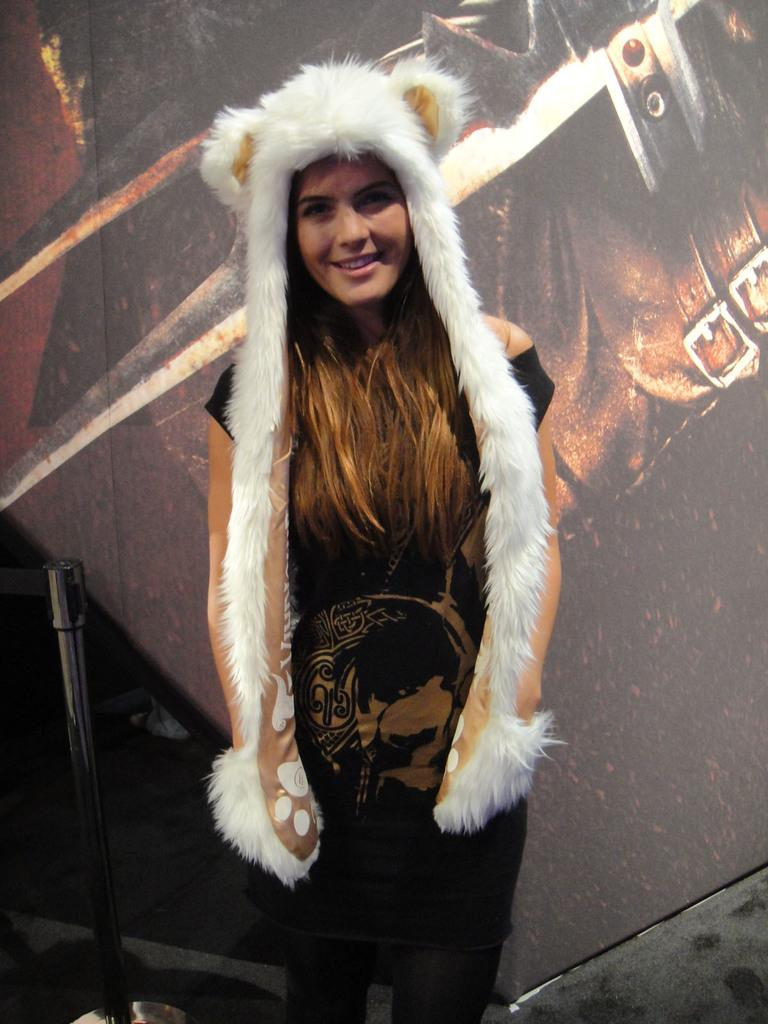What is the main subject of the image? The main subject of the image is a woman. What is the woman wearing in the image? The woman is wearing a black dress in the image. What is the woman's facial expression in the image? The woman is smiling in the image. What type of agreement is the woman signing in the image? There is no agreement or signing activity depicted in the image; the woman is simply smiling. What type of treatment is the woman receiving from the queen in the image? There is no queen or treatment activity depicted in the image; the woman is simply wearing a black dress and smiling. 